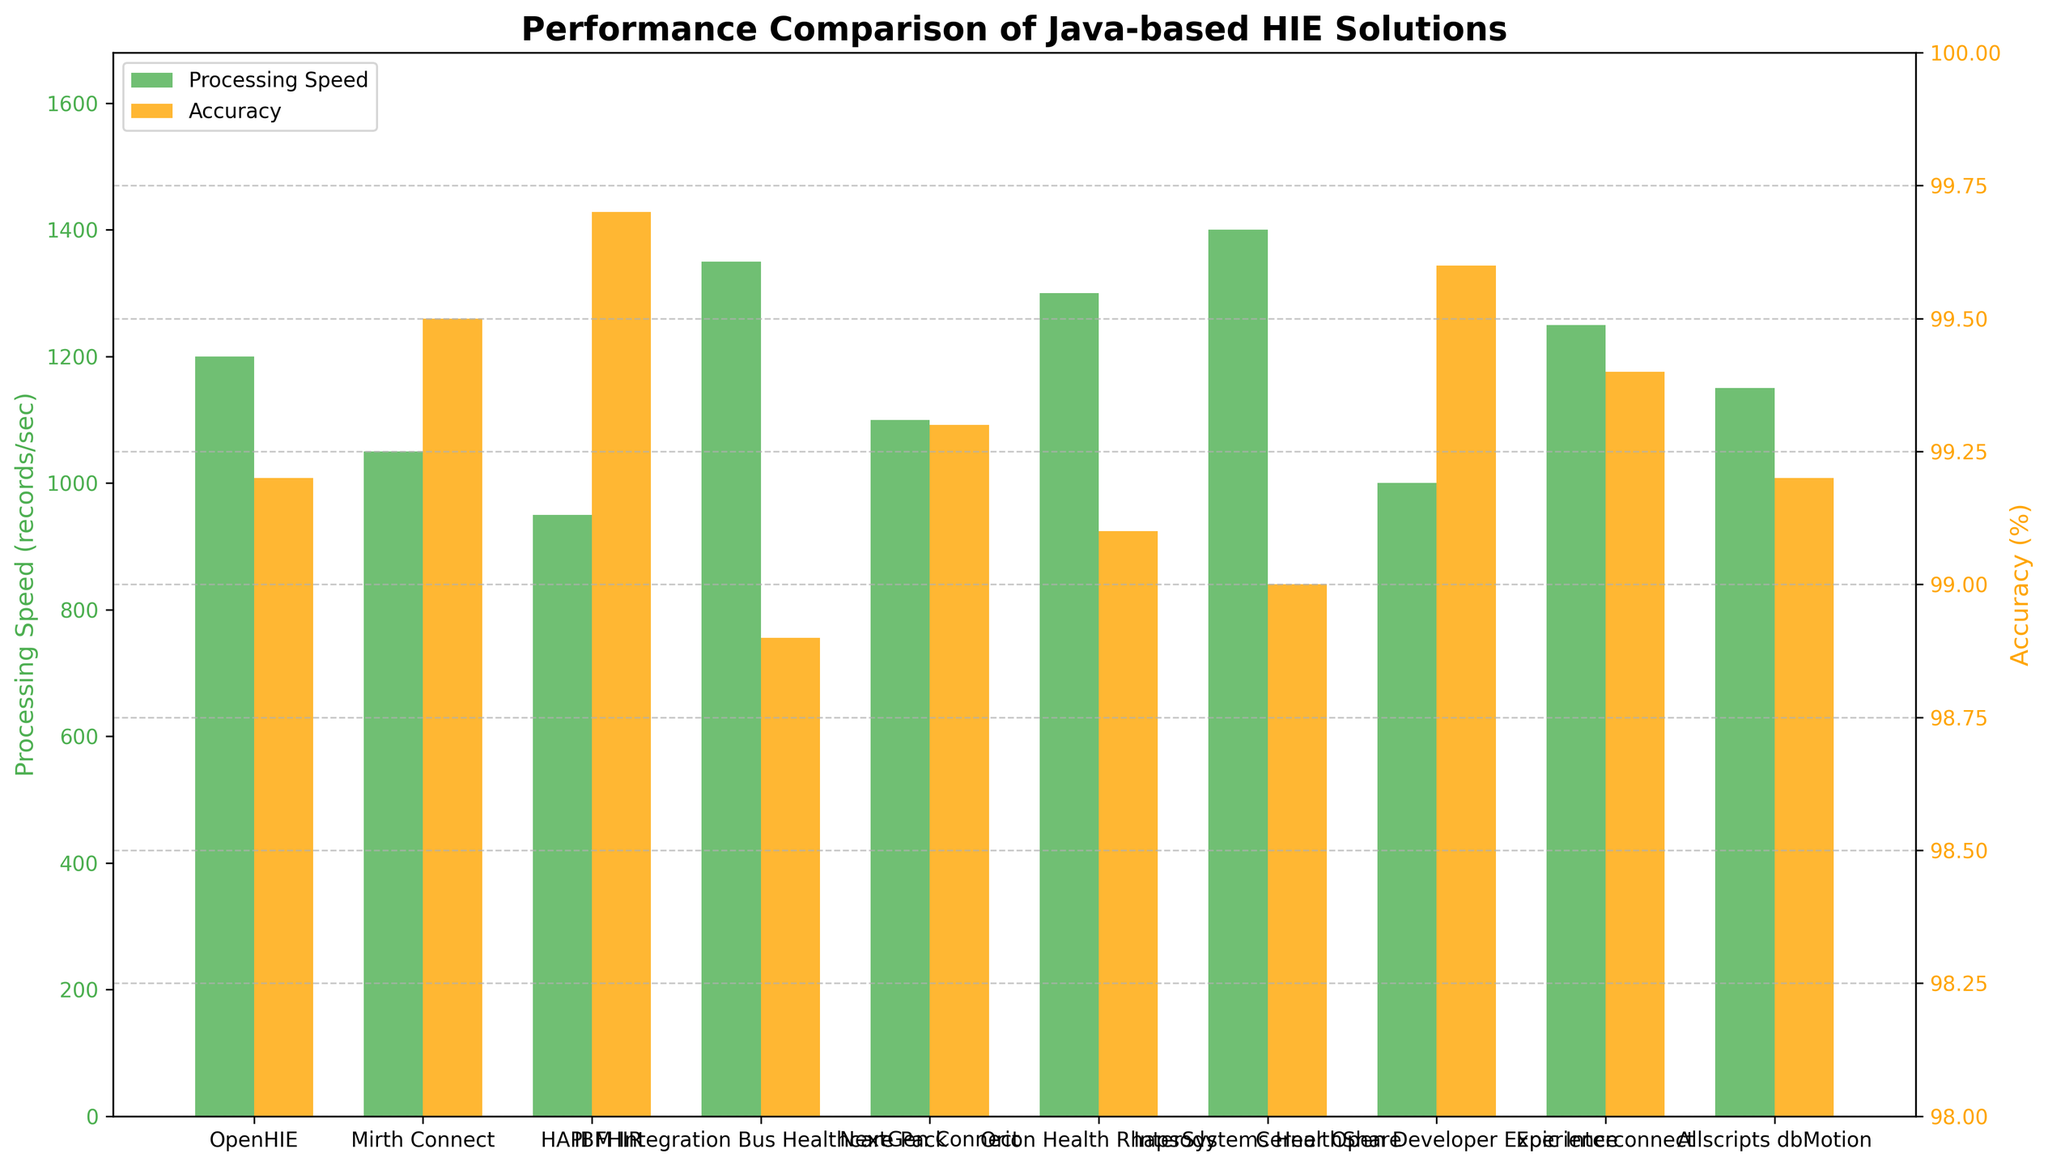Which solution has the highest processing speed? By observing the bar heights for processing speed, we identify the tallest bar, representing InterSystems HealthShare with a speed of 1400 records/sec.
Answer: InterSystems HealthShare Which solution has the highest accuracy? By observing the bar heights for accuracy, we identify the tallest bar, representing HAPI FHIR with an accuracy of 99.7%.
Answer: HAPI FHIR How much higher is the processing speed of InterSystems HealthShare compared to Mirth Connect? The processing speed of InterSystems HealthShare is 1400 records/sec and Mirth Connect is 1050 records/sec. The difference is 1400 - 1050 = 350 records/sec.
Answer: 350 records/sec Which solution has both above-average processing speed and above-average accuracy? The average processing speed is the sum of all processing speeds divided by the number of solutions: (1200 + 1050 + 950 + 1350 + 1100 + 1300 + 1400 + 1000 + 1250 + 1150) / 10 = 1175 records/sec. The average accuracy is (99.2 + 99.5 + 99.7 + 98.9 + 99.3 + 99.1 + 99.0 + 99.6 + 99.4 + 99.2) / 10 = 99.3%. Checking each solution, Cerner Open Developer Experience has a processing speed of 1000 records/sec and accuracy of 99.6%, neither of which is above average, so there is actually no single solution that meets both criteria.
Answer: None What are the solutions with processing speeds greater than 1200 records/sec? By examining the bars for processing speeds, the solutions with speeds greater than 1200 records/sec are IBM Integration Bus Healthcare Pack (1350), Orion Health Rhapsody (1300), InterSystems HealthShare (1400), and Epic Interconnect (1250).
Answer: IBM Integration Bus Healthcare Pack, Orion Health Rhapsody, InterSystems HealthShare, Epic Interconnect Which solution has the largest discrepancy between processing speed and accuracy? We need to find the solution with the greatest difference between processing speed (in records/sec) and accuracy (in percentage). InterSystems HealthShare has a significant discrepancy with 1400 records/sec and 99.0%, which translates to a 400-records/sec disparity from its highest processing speed to accuracy rate.
Answer: InterSystems HealthShare How does the processing speed of OpenHIE compare to the average processing speed? The processing speed of OpenHIE is 1200 records/sec. The average processing speed, as calculated earlier, is 1175 records/sec. Since 1200 is greater than 1175, OpenHIE's processing speed is above average.
Answer: Above average 